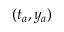<formula> <loc_0><loc_0><loc_500><loc_500>( t _ { a } , y _ { a } )</formula> 